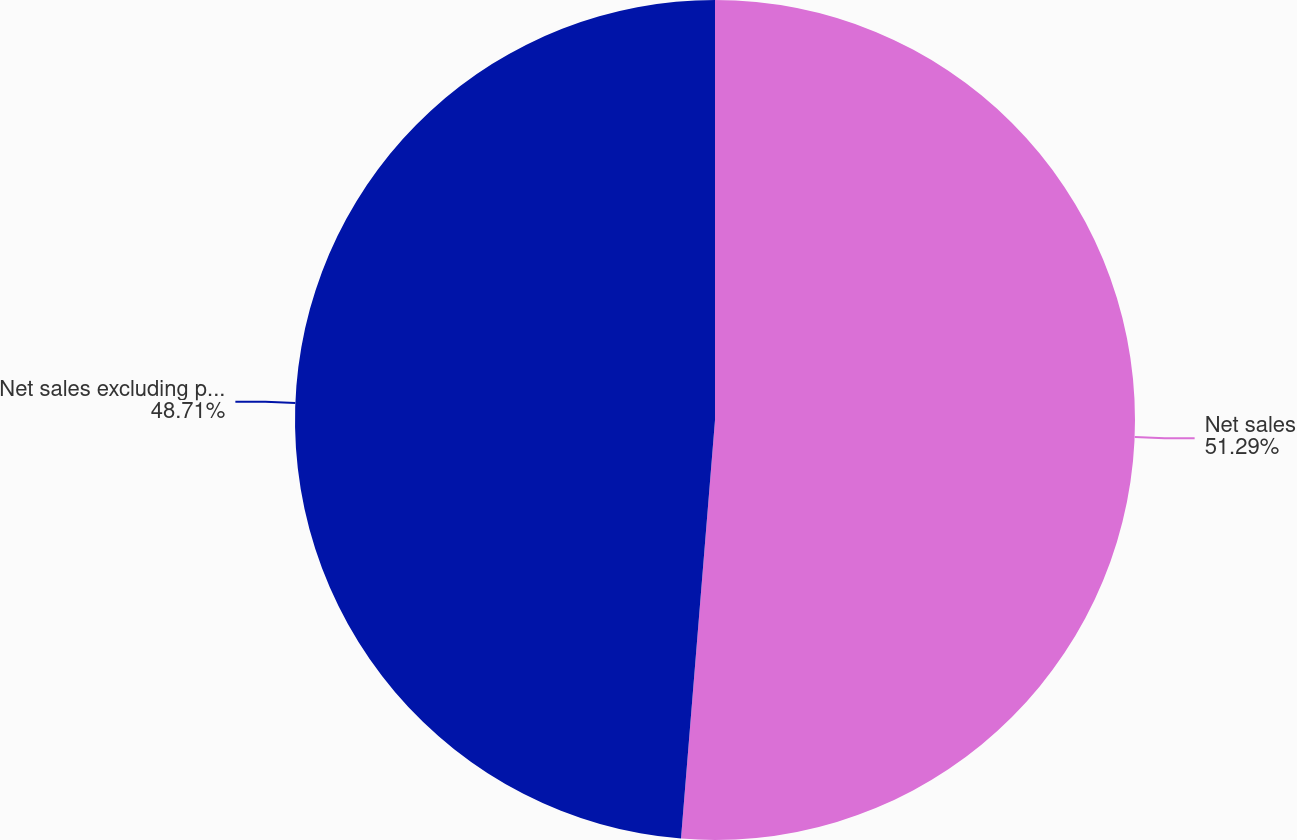Convert chart to OTSL. <chart><loc_0><loc_0><loc_500><loc_500><pie_chart><fcel>Net sales<fcel>Net sales excluding precious<nl><fcel>51.29%<fcel>48.71%<nl></chart> 